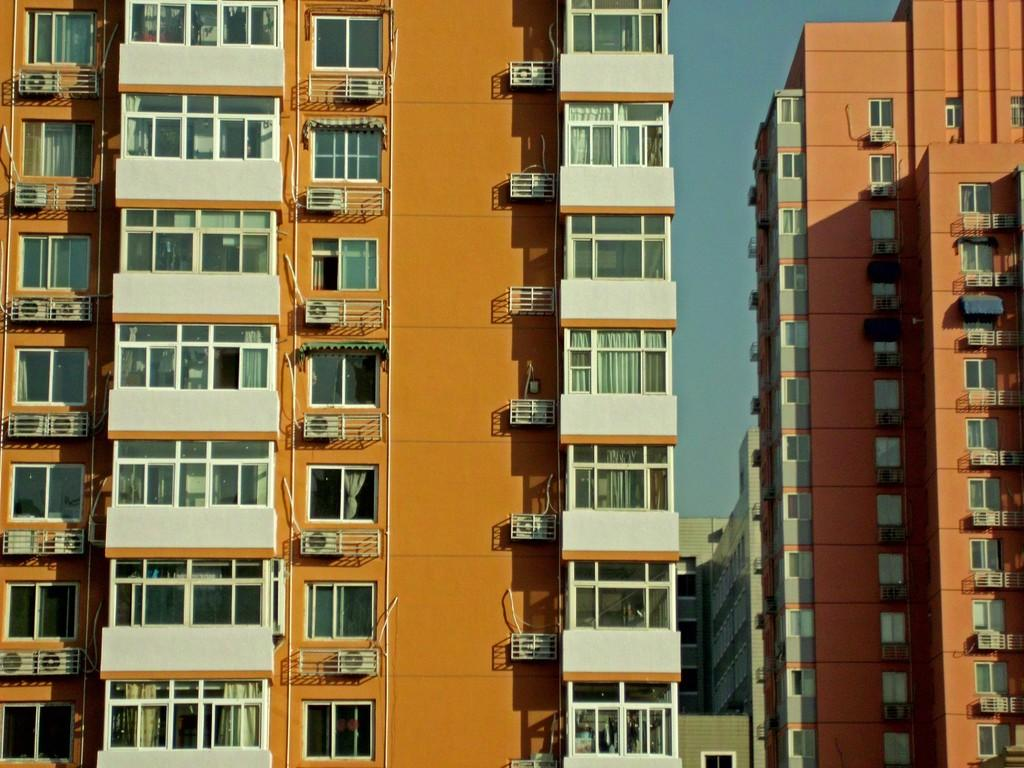What type of structures are located in the center of the image? There are buildings with windows in the center of the image. What can be seen at the top of the image? The sky is visible at the top of the image. Where is the van parked in the image? There is no van present in the image. Can you see a volleyball game being played in the image? There is no volleyball game visible in the image. 